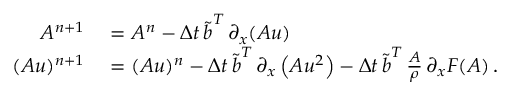Convert formula to latex. <formula><loc_0><loc_0><loc_500><loc_500>\begin{array} { r l } { A ^ { n + 1 } } & = A ^ { n } - \Delta t \, \tilde { b } ^ { T } \, \partial _ { x } ( A u ) } \\ { ( A u ) ^ { n + 1 } } & = ( A u ) ^ { n } - \Delta t \, \tilde { b } ^ { T } \, \partial _ { x } \left ( A u ^ { 2 } \right ) - \Delta t \, \tilde { b } ^ { T } \, \frac { A } { \rho } \, \partial _ { x } F ( A ) \, . } \end{array}</formula> 